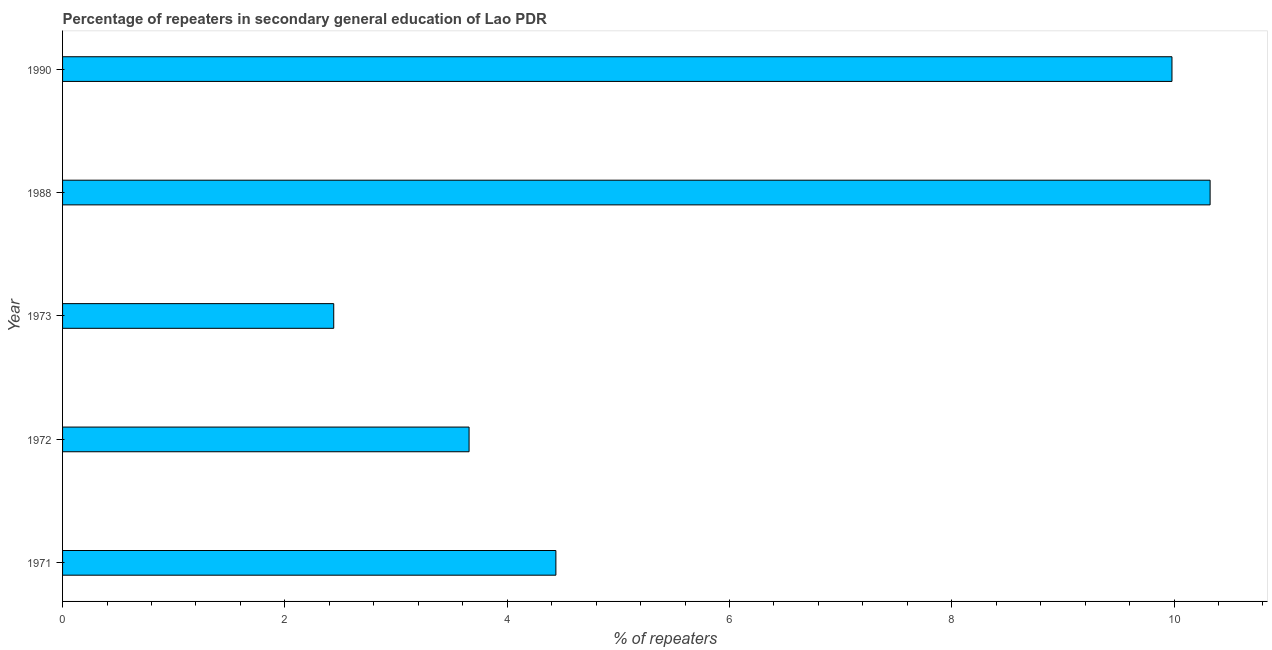Does the graph contain any zero values?
Provide a succinct answer. No. Does the graph contain grids?
Your answer should be very brief. No. What is the title of the graph?
Make the answer very short. Percentage of repeaters in secondary general education of Lao PDR. What is the label or title of the X-axis?
Provide a short and direct response. % of repeaters. What is the label or title of the Y-axis?
Your answer should be compact. Year. What is the percentage of repeaters in 1990?
Offer a terse response. 9.98. Across all years, what is the maximum percentage of repeaters?
Give a very brief answer. 10.32. Across all years, what is the minimum percentage of repeaters?
Give a very brief answer. 2.44. In which year was the percentage of repeaters maximum?
Offer a terse response. 1988. What is the sum of the percentage of repeaters?
Ensure brevity in your answer.  30.84. What is the difference between the percentage of repeaters in 1972 and 1973?
Offer a terse response. 1.22. What is the average percentage of repeaters per year?
Keep it short and to the point. 6.17. What is the median percentage of repeaters?
Offer a very short reply. 4.44. Do a majority of the years between 1973 and 1988 (inclusive) have percentage of repeaters greater than 0.4 %?
Provide a short and direct response. Yes. What is the ratio of the percentage of repeaters in 1972 to that in 1990?
Your response must be concise. 0.37. Is the percentage of repeaters in 1971 less than that in 1972?
Offer a terse response. No. What is the difference between the highest and the second highest percentage of repeaters?
Your response must be concise. 0.34. What is the difference between the highest and the lowest percentage of repeaters?
Provide a succinct answer. 7.88. In how many years, is the percentage of repeaters greater than the average percentage of repeaters taken over all years?
Provide a short and direct response. 2. Are all the bars in the graph horizontal?
Ensure brevity in your answer.  Yes. What is the difference between two consecutive major ticks on the X-axis?
Offer a very short reply. 2. Are the values on the major ticks of X-axis written in scientific E-notation?
Offer a terse response. No. What is the % of repeaters of 1971?
Make the answer very short. 4.44. What is the % of repeaters of 1972?
Your answer should be compact. 3.66. What is the % of repeaters of 1973?
Ensure brevity in your answer.  2.44. What is the % of repeaters of 1988?
Offer a very short reply. 10.32. What is the % of repeaters of 1990?
Keep it short and to the point. 9.98. What is the difference between the % of repeaters in 1971 and 1972?
Offer a very short reply. 0.78. What is the difference between the % of repeaters in 1971 and 1973?
Provide a short and direct response. 2. What is the difference between the % of repeaters in 1971 and 1988?
Your answer should be very brief. -5.89. What is the difference between the % of repeaters in 1971 and 1990?
Your answer should be compact. -5.54. What is the difference between the % of repeaters in 1972 and 1973?
Offer a very short reply. 1.22. What is the difference between the % of repeaters in 1972 and 1988?
Your answer should be compact. -6.67. What is the difference between the % of repeaters in 1972 and 1990?
Your answer should be compact. -6.32. What is the difference between the % of repeaters in 1973 and 1988?
Offer a very short reply. -7.88. What is the difference between the % of repeaters in 1973 and 1990?
Offer a terse response. -7.54. What is the difference between the % of repeaters in 1988 and 1990?
Provide a short and direct response. 0.34. What is the ratio of the % of repeaters in 1971 to that in 1972?
Make the answer very short. 1.21. What is the ratio of the % of repeaters in 1971 to that in 1973?
Provide a succinct answer. 1.82. What is the ratio of the % of repeaters in 1971 to that in 1988?
Your answer should be very brief. 0.43. What is the ratio of the % of repeaters in 1971 to that in 1990?
Your answer should be very brief. 0.45. What is the ratio of the % of repeaters in 1972 to that in 1973?
Offer a very short reply. 1.5. What is the ratio of the % of repeaters in 1972 to that in 1988?
Provide a succinct answer. 0.35. What is the ratio of the % of repeaters in 1972 to that in 1990?
Give a very brief answer. 0.37. What is the ratio of the % of repeaters in 1973 to that in 1988?
Give a very brief answer. 0.24. What is the ratio of the % of repeaters in 1973 to that in 1990?
Your answer should be compact. 0.24. What is the ratio of the % of repeaters in 1988 to that in 1990?
Your response must be concise. 1.03. 